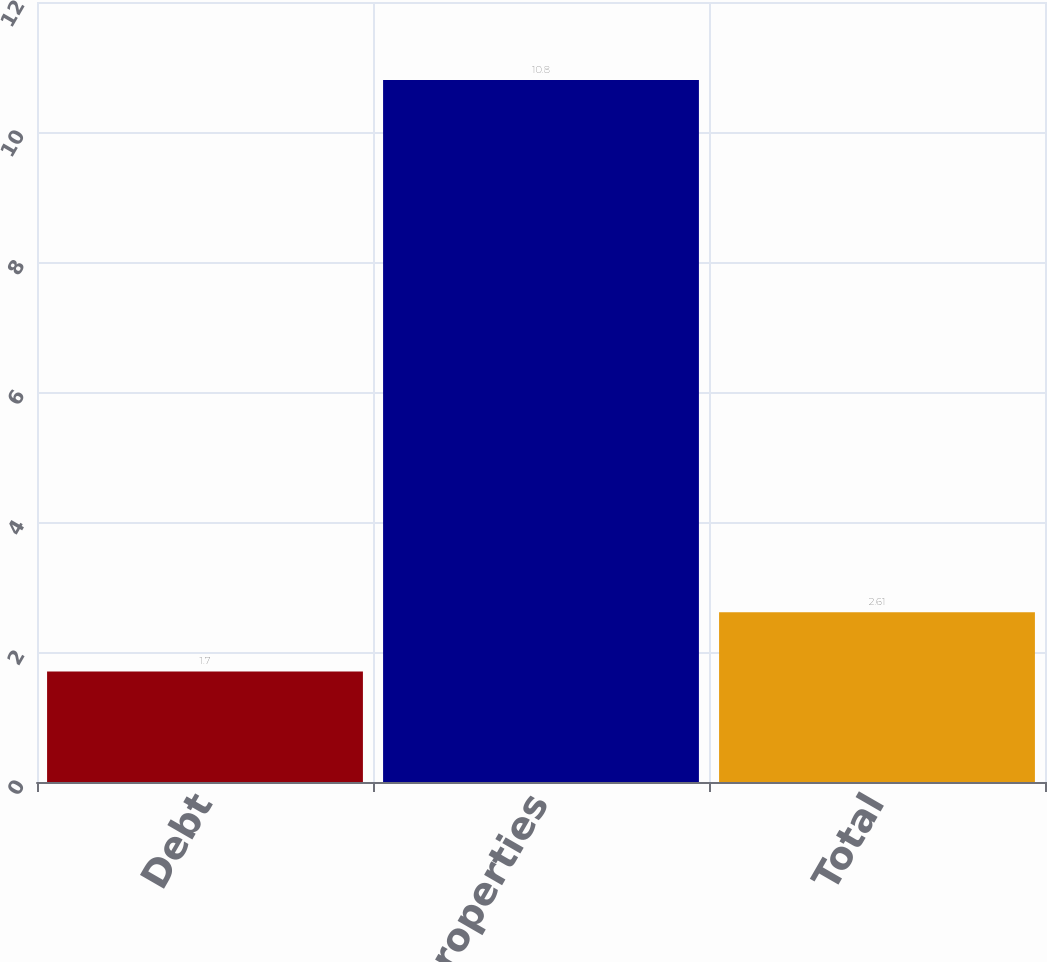Convert chart to OTSL. <chart><loc_0><loc_0><loc_500><loc_500><bar_chart><fcel>Debt<fcel>Business Properties<fcel>Total<nl><fcel>1.7<fcel>10.8<fcel>2.61<nl></chart> 